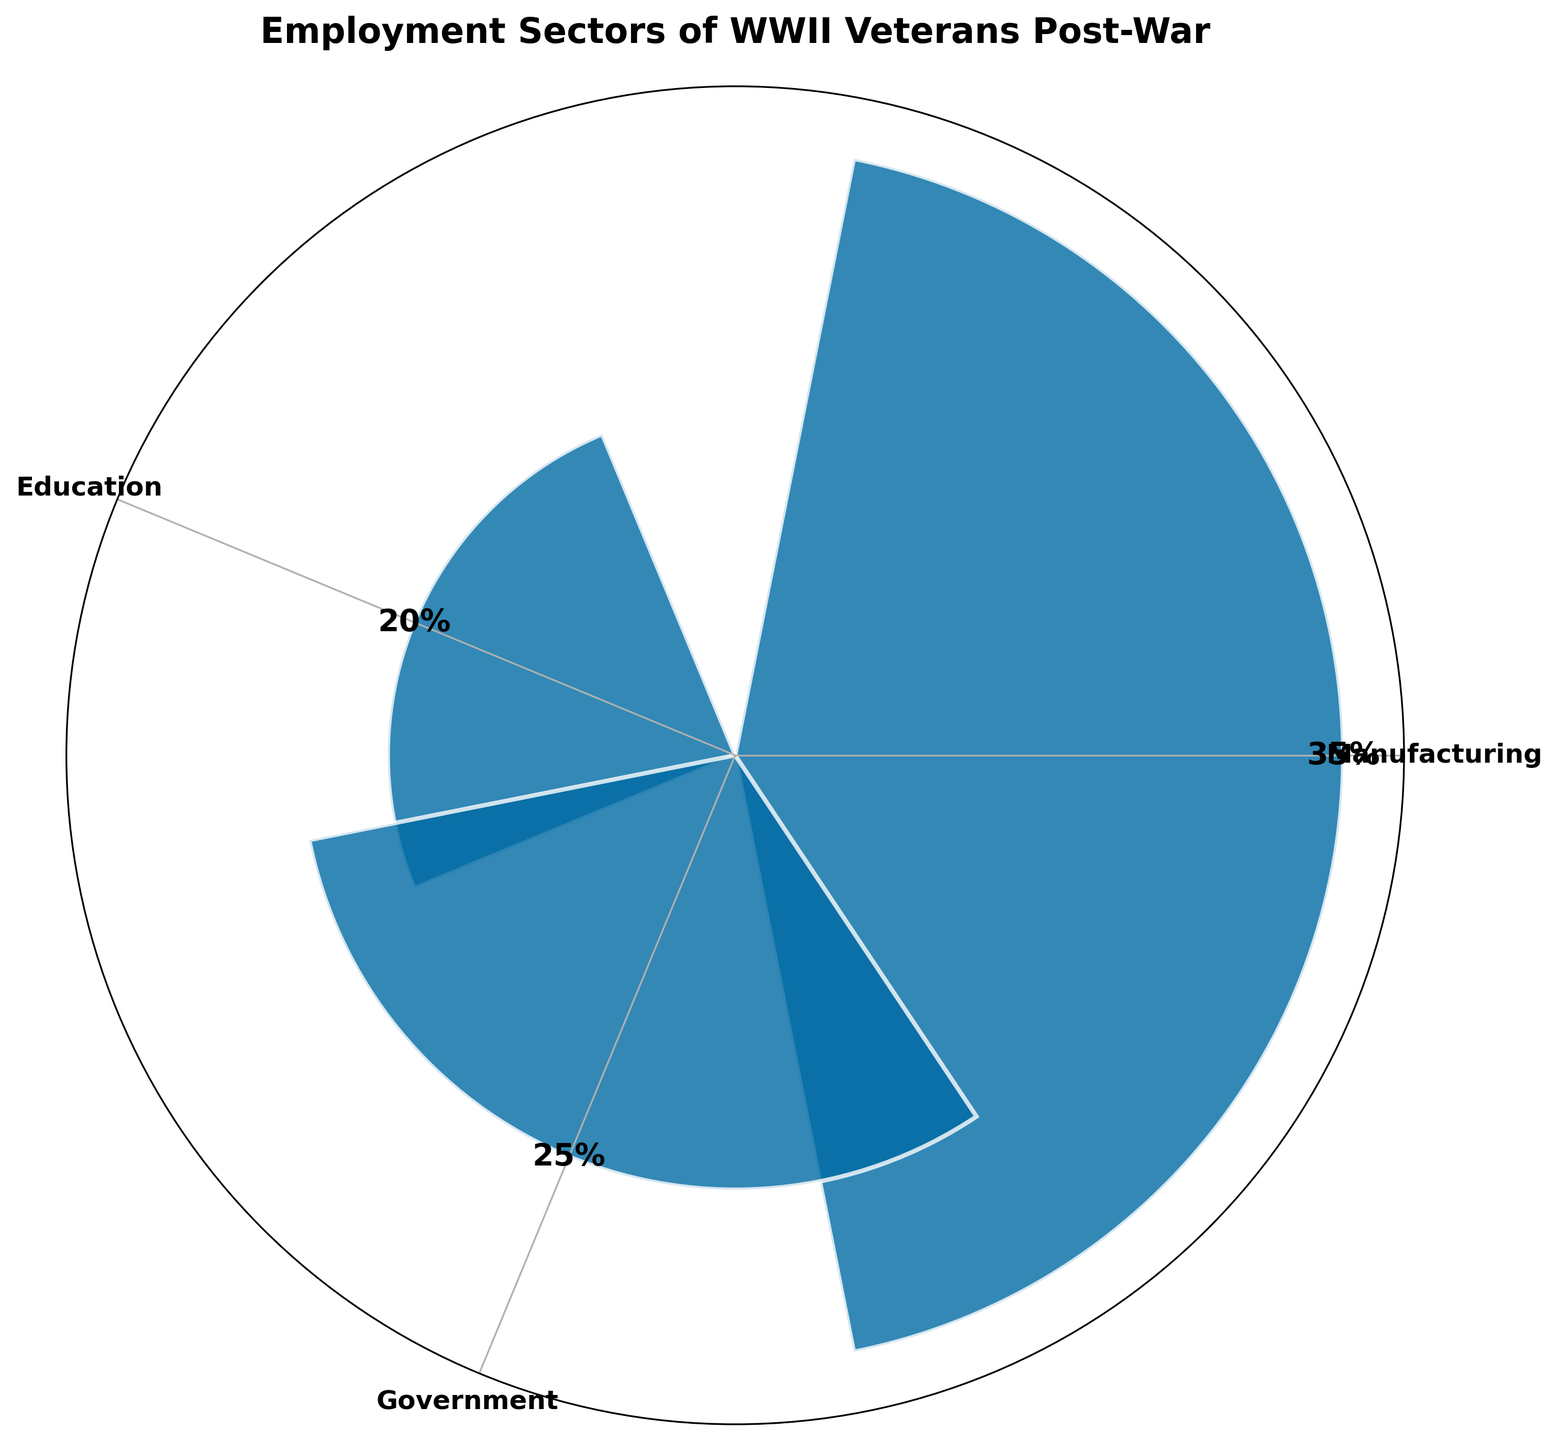What is the title of the chart? The chart's title is usually displayed at the top and summarizes what the chart is about. Here, the title is "Employment Sectors of WWII Veterans Post-War," indicating the data shown pertains to the employment sectors where WWII veterans worked after the war.
Answer: Employment Sectors of WWII Veterans Post-War How many sectors are shown in the chart? The chart visually represents segments corresponding to different sectors of employment. By counting these segments, we can determine the number of sectors. There are three sectors displayed.
Answer: 3 Which sector has the highest percentage of WWII veterans? Examining the height of the bars in the polar plot shows which sector has the highest percentage. The Manufacturing sector has the highest bar.
Answer: Manufacturing What is the combined percentage of veterans in the Education and Healthcare sectors? To find the combined percentage, add the percentages of the Education and Healthcare sectors. Education is 20% and Healthcare is 20%, so their sum is 20% + 20%.
Answer: 40% Which sector has the smallest percentage of WWII veterans? Check the heights of the bars and locate the shortest bar to determine the smallest percentage. Both the Education and Healthcare sectors share the smallest percentage of 20%.
Answer: Education and Healthcare Is the percentage of veterans in the Government sector greater than the combined percentage in Education and Healthcare sectors? First, find the percentage of veterans in the Government sector, which is 25%. Then, find the combined percentage of Education and Healthcare, which is 20% + 20% = 40%. Since 25% is less than 40%, the answer is no.
Answer: No What percentage of veterans worked in the Government sector? The label on the bar representing the Government sector gives the percentage directly, which is 25%.
Answer: 25% Compare the percentages of Manufacturing and Government sectors. Which one is greater and by how much? Manufacturing is 35% and Government is 25%. Subtract the smaller percentage from the larger one: 35% - 25% = 10%. Therefore, the Manufacturing sector is greater by 10%.
Answer: Manufacturing, by 10% What is the average percentage across the displayed sectors? Add the percentages of all displayed sectors and divide by the number of sectors: (35% + 20% + 25%) / 3. This simplifies to 80% / 3, which is approximately 26.67%.
Answer: 26.67% Does the Healthcare sector share the same percentage with any other sector? Compare the percentage of the Healthcare sector with other sectors. Healthcare and Education both have 20%, indicating they share the same percentage.
Answer: Yes, with Education 